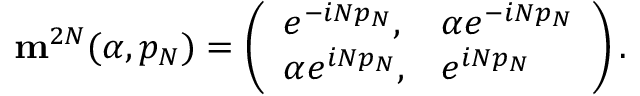<formula> <loc_0><loc_0><loc_500><loc_500>{ \mathbf m } ^ { 2 N } ( \alpha , p _ { N } ) = \left ( \begin{array} { l l } { { e ^ { - i N p _ { N } } , } } & { { \alpha e ^ { - i N p _ { N } } } } \\ { { \alpha e ^ { i N p _ { N } } , } } & { { e ^ { i N p _ { N } } } } \end{array} \right ) .</formula> 